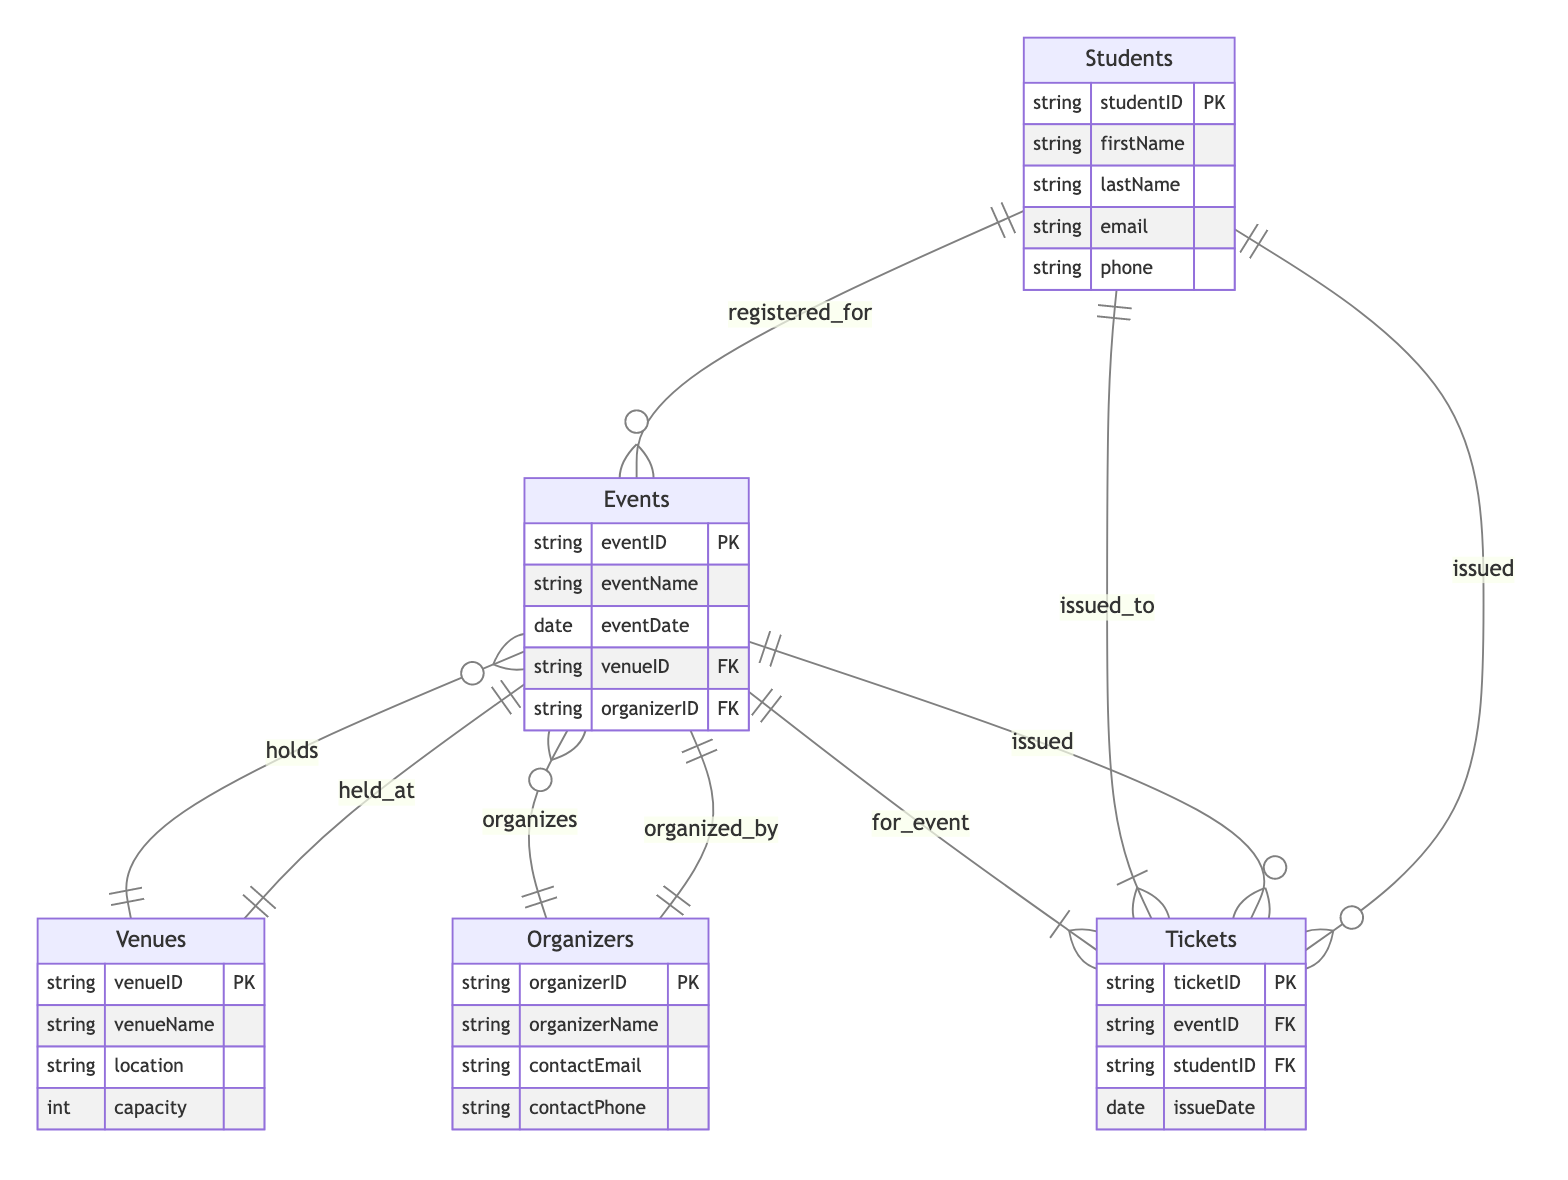What entities are present in the diagram? The entities mentioned in the diagram are Students, Events, Venues, Organizers, and Tickets. They represent the main components of the Campus Event Management System.
Answer: Students, Events, Venues, Organizers, Tickets How many attributes does the Events entity have? The Events entity has five attributes: eventID, eventName, eventDate, venueID, and organizerID. Counting these gives a total of five attributes.
Answer: 5 What relationship connects Students and Events? Students and Events are connected by the "registered_for" relationship, indicating that students register for events.
Answer: registered_for Which entity holds the capacity attribute? The capacity attribute is included in the Venues entity, which details the venue's capacity for hosting events.
Answer: Venues What is the primary key of the Tickets entity? The primary key of the Tickets entity is ticketID, which uniquely identifies each ticket issued.
Answer: ticketID How many relationships are associated with the Events entity? The Events entity is associated with four relationships: held_at (with Venues), organized_by (with Organizers), registered_by (with Students), and issued (with Tickets). This totals four relationships.
Answer: 4 What does the relationship "issued_to" signify in this diagram? The "issued_to" relationship connects Tickets to Students, indicating that tickets are issued specifically to students.
Answer: issued_to Which entity is connected to Organizers through an organizing relationship? The Events entity is connected to Organizers via the "organizes" relationship, indicating that organizers are responsible for organizing the events.
Answer: Events What is the foreign key in the Events entity? The foreign keys in the Events entity are venueID and organizerID. They link to the Venues and Organizers entities, respectively, establishing relationships with these entities.
Answer: venueID, organizerID 